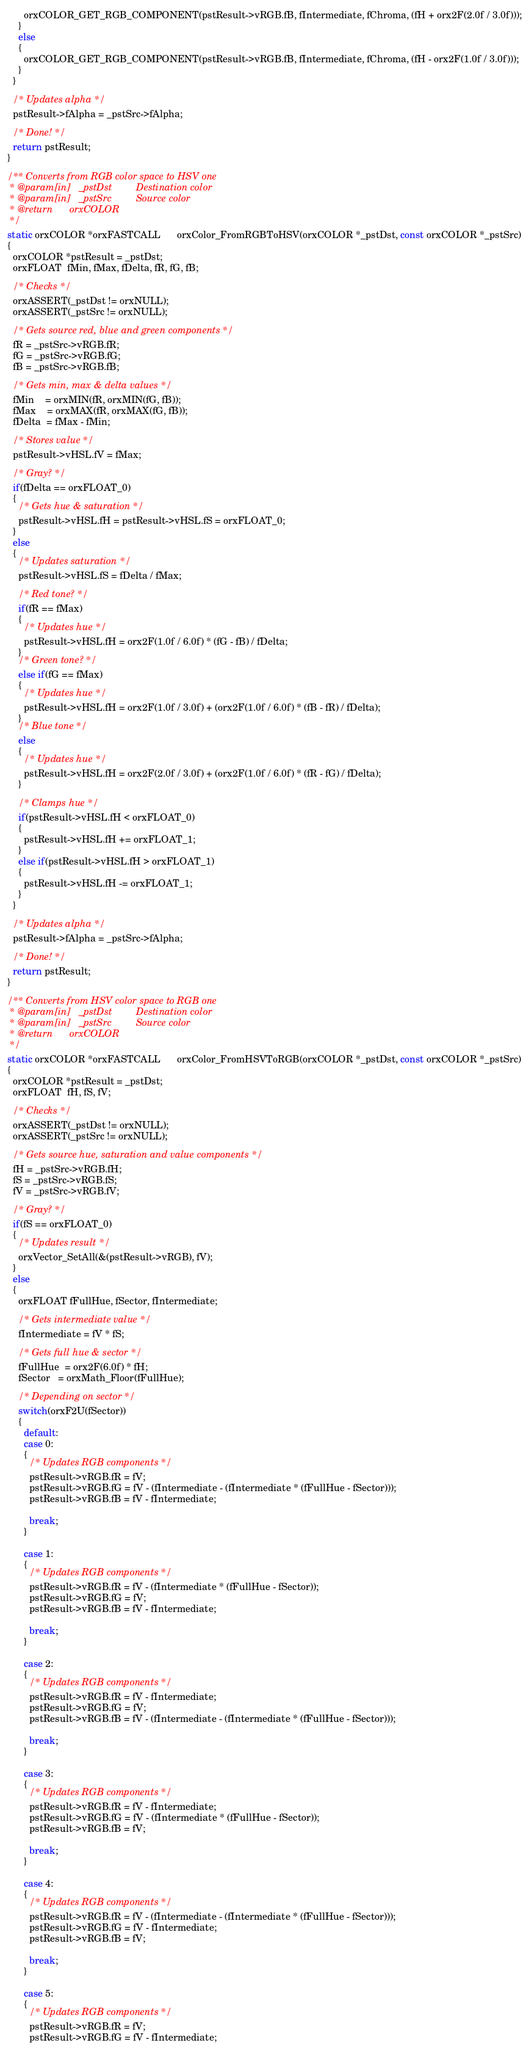Convert code to text. <code><loc_0><loc_0><loc_500><loc_500><_C_>      orxCOLOR_GET_RGB_COMPONENT(pstResult->vRGB.fB, fIntermediate, fChroma, (fH + orx2F(2.0f / 3.0f)));
    }
    else
    {
      orxCOLOR_GET_RGB_COMPONENT(pstResult->vRGB.fB, fIntermediate, fChroma, (fH - orx2F(1.0f / 3.0f)));
    }
  }

  /* Updates alpha */
  pstResult->fAlpha = _pstSrc->fAlpha;

  /* Done! */
  return pstResult;
}

/** Converts from RGB color space to HSV one
 * @param[in]   _pstDst         Destination color
 * @param[in]   _pstSrc         Source color
 * @return      orxCOLOR
 */
static orxCOLOR *orxFASTCALL      orxColor_FromRGBToHSV(orxCOLOR *_pstDst, const orxCOLOR *_pstSrc)
{
  orxCOLOR *pstResult = _pstDst;
  orxFLOAT  fMin, fMax, fDelta, fR, fG, fB;

  /* Checks */
  orxASSERT(_pstDst != orxNULL);
  orxASSERT(_pstSrc != orxNULL);

  /* Gets source red, blue and green components */
  fR = _pstSrc->vRGB.fR;
  fG = _pstSrc->vRGB.fG;
  fB = _pstSrc->vRGB.fB;

  /* Gets min, max & delta values */
  fMin    = orxMIN(fR, orxMIN(fG, fB));
  fMax    = orxMAX(fR, orxMAX(fG, fB));
  fDelta  = fMax - fMin;

  /* Stores value */
  pstResult->vHSL.fV = fMax;

  /* Gray? */
  if(fDelta == orxFLOAT_0)
  {
    /* Gets hue & saturation */
    pstResult->vHSL.fH = pstResult->vHSL.fS = orxFLOAT_0;
  }
  else
  {
    /* Updates saturation */
    pstResult->vHSL.fS = fDelta / fMax;

    /* Red tone? */
    if(fR == fMax)
    {
      /* Updates hue */
      pstResult->vHSL.fH = orx2F(1.0f / 6.0f) * (fG - fB) / fDelta;
    }
    /* Green tone? */
    else if(fG == fMax)
    {
      /* Updates hue */
      pstResult->vHSL.fH = orx2F(1.0f / 3.0f) + (orx2F(1.0f / 6.0f) * (fB - fR) / fDelta);
    }
    /* Blue tone */
    else
    {
      /* Updates hue */
      pstResult->vHSL.fH = orx2F(2.0f / 3.0f) + (orx2F(1.0f / 6.0f) * (fR - fG) / fDelta);
    }

    /* Clamps hue */
    if(pstResult->vHSL.fH < orxFLOAT_0)
    {
      pstResult->vHSL.fH += orxFLOAT_1;
    }
    else if(pstResult->vHSL.fH > orxFLOAT_1)
    {
      pstResult->vHSL.fH -= orxFLOAT_1;
    }
  }

  /* Updates alpha */
  pstResult->fAlpha = _pstSrc->fAlpha;

  /* Done! */
  return pstResult;
}

/** Converts from HSV color space to RGB one
 * @param[in]   _pstDst         Destination color
 * @param[in]   _pstSrc         Source color
 * @return      orxCOLOR
 */
static orxCOLOR *orxFASTCALL      orxColor_FromHSVToRGB(orxCOLOR *_pstDst, const orxCOLOR *_pstSrc)
{
  orxCOLOR *pstResult = _pstDst;
  orxFLOAT  fH, fS, fV;

  /* Checks */
  orxASSERT(_pstDst != orxNULL);
  orxASSERT(_pstSrc != orxNULL);

  /* Gets source hue, saturation and value components */
  fH = _pstSrc->vRGB.fH;
  fS = _pstSrc->vRGB.fS;
  fV = _pstSrc->vRGB.fV;

  /* Gray? */
  if(fS == orxFLOAT_0)
  {
    /* Updates result */
    orxVector_SetAll(&(pstResult->vRGB), fV);
  }
  else
  {
    orxFLOAT fFullHue, fSector, fIntermediate;

    /* Gets intermediate value */
    fIntermediate = fV * fS;

    /* Gets full hue & sector */
    fFullHue  = orx2F(6.0f) * fH;
    fSector   = orxMath_Floor(fFullHue);

    /* Depending on sector */
    switch(orxF2U(fSector))
    {
      default:
      case 0:
      {
        /* Updates RGB components */
        pstResult->vRGB.fR = fV;
        pstResult->vRGB.fG = fV - (fIntermediate - (fIntermediate * (fFullHue - fSector)));
        pstResult->vRGB.fB = fV - fIntermediate;

        break;
      }

      case 1:
      {
        /* Updates RGB components */
        pstResult->vRGB.fR = fV - (fIntermediate * (fFullHue - fSector));
        pstResult->vRGB.fG = fV;
        pstResult->vRGB.fB = fV - fIntermediate;

        break;
      }

      case 2:
      {
        /* Updates RGB components */
        pstResult->vRGB.fR = fV - fIntermediate;
        pstResult->vRGB.fG = fV;
        pstResult->vRGB.fB = fV - (fIntermediate - (fIntermediate * (fFullHue - fSector)));

        break;
      }

      case 3:
      {
        /* Updates RGB components */
        pstResult->vRGB.fR = fV - fIntermediate;
        pstResult->vRGB.fG = fV - (fIntermediate * (fFullHue - fSector));
        pstResult->vRGB.fB = fV;

        break;
      }

      case 4:
      {
        /* Updates RGB components */
        pstResult->vRGB.fR = fV - (fIntermediate - (fIntermediate * (fFullHue - fSector)));
        pstResult->vRGB.fG = fV - fIntermediate;
        pstResult->vRGB.fB = fV;

        break;
      }

      case 5:
      {
        /* Updates RGB components */
        pstResult->vRGB.fR = fV;
        pstResult->vRGB.fG = fV - fIntermediate;</code> 